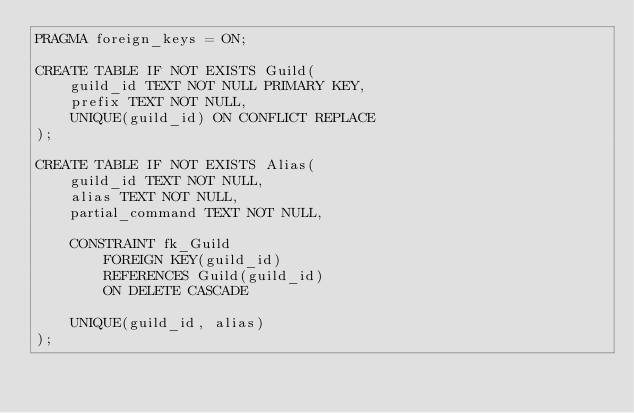Convert code to text. <code><loc_0><loc_0><loc_500><loc_500><_SQL_>PRAGMA foreign_keys = ON;

CREATE TABLE IF NOT EXISTS Guild(
    guild_id TEXT NOT NULL PRIMARY KEY,
    prefix TEXT NOT NULL,
    UNIQUE(guild_id) ON CONFLICT REPLACE
);

CREATE TABLE IF NOT EXISTS Alias(
    guild_id TEXT NOT NULL,
    alias TEXT NOT NULL,
    partial_command TEXT NOT NULL,

    CONSTRAINT fk_Guild
        FOREIGN KEY(guild_id)
        REFERENCES Guild(guild_id)
        ON DELETE CASCADE
    
    UNIQUE(guild_id, alias)
);
</code> 